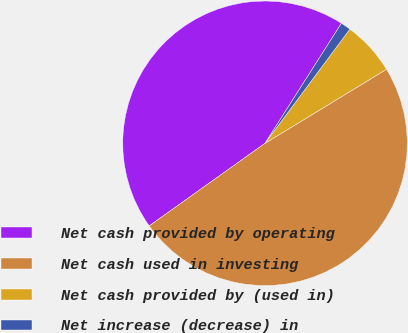Convert chart. <chart><loc_0><loc_0><loc_500><loc_500><pie_chart><fcel>Net cash provided by operating<fcel>Net cash used in investing<fcel>Net cash provided by (used in)<fcel>Net increase (decrease) in<nl><fcel>43.88%<fcel>48.85%<fcel>6.12%<fcel>1.15%<nl></chart> 